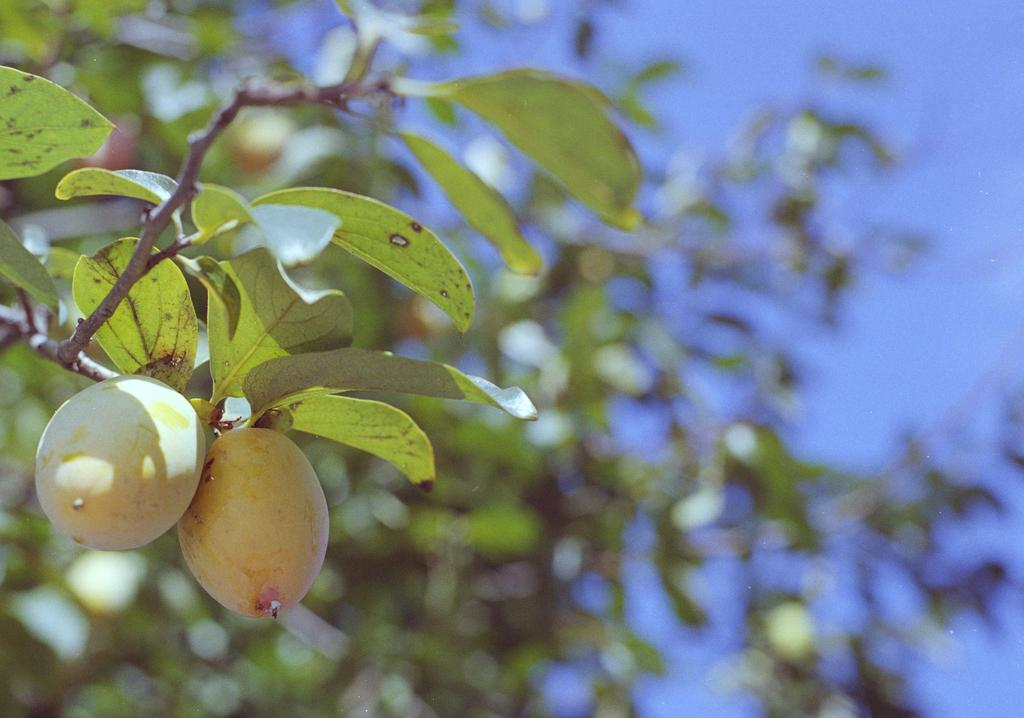What type of fruits can be seen on the tree in the image? There are fruits on the tree in the image. What else can be seen on the tree besides the fruits? There are green leaves on the tree in the image. What is visible in the background of the image? The sky is visible in the background of the image. Can you see any slaves working on the tree in the image? There is no mention of slaves or any human presence in the image; it features a tree with fruits and green leaves. What type of bait is used to catch fish in the image? There is no fishing or bait present in the image; it features a tree with fruits and green leaves. 